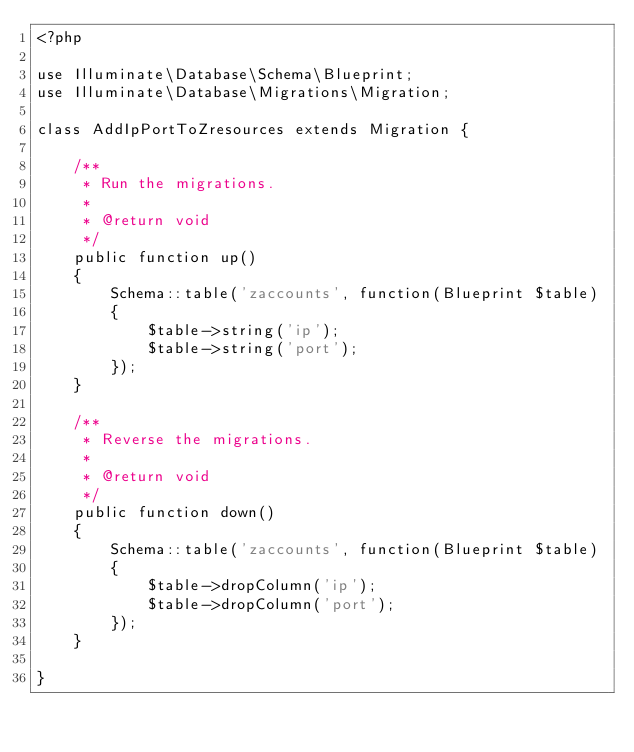Convert code to text. <code><loc_0><loc_0><loc_500><loc_500><_PHP_><?php

use Illuminate\Database\Schema\Blueprint;
use Illuminate\Database\Migrations\Migration;

class AddIpPortToZresources extends Migration {

	/**
	 * Run the migrations.
	 *
	 * @return void
	 */
	public function up()
	{
		Schema::table('zaccounts', function(Blueprint $table)
		{
			$table->string('ip');
            $table->string('port');
		});
	}

	/**
	 * Reverse the migrations.
	 *
	 * @return void
	 */
	public function down()
	{
		Schema::table('zaccounts', function(Blueprint $table)
		{
			$table->dropColumn('ip');
            $table->dropColumn('port');
		});
	}

}
</code> 